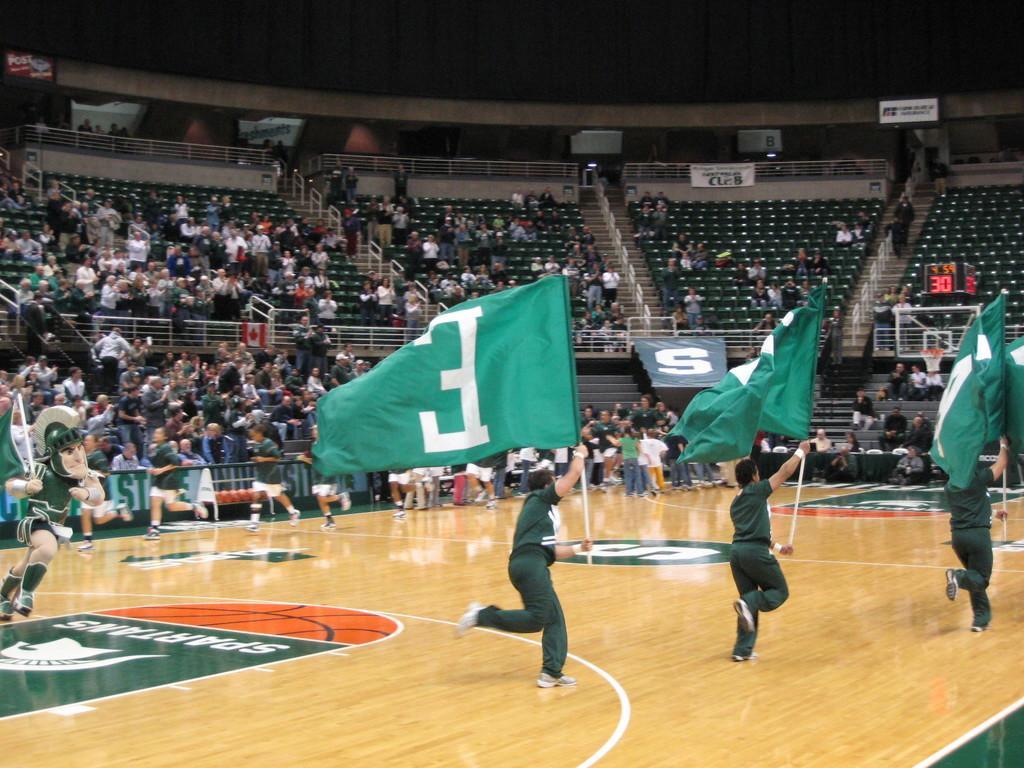In one or two sentences, can you explain what this image depicts? In this picture I can see group of people among them some are sitting on chairs and some are standing on the floor. In the front of the image I can see some people running by holding flags. In the background I can see chairs and fence. I can also see boards attached to the wall. 